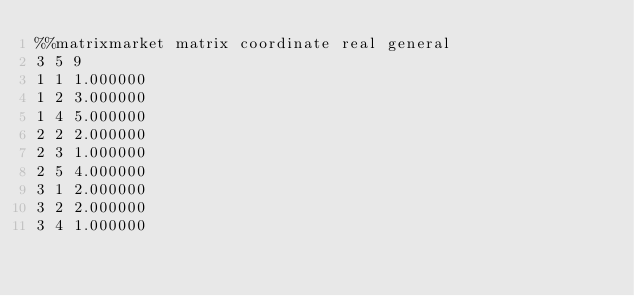<code> <loc_0><loc_0><loc_500><loc_500><_ObjectiveC_>%%matrixmarket matrix coordinate real general
3 5 9
1 1 1.000000
1 2 3.000000
1 4 5.000000
2 2 2.000000
2 3 1.000000
2 5 4.000000
3 1 2.000000
3 2 2.000000
3 4 1.000000</code> 